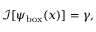<formula> <loc_0><loc_0><loc_500><loc_500>\mathcal { I } [ \psi _ { b o x } ( x ) ] = \gamma ,</formula> 